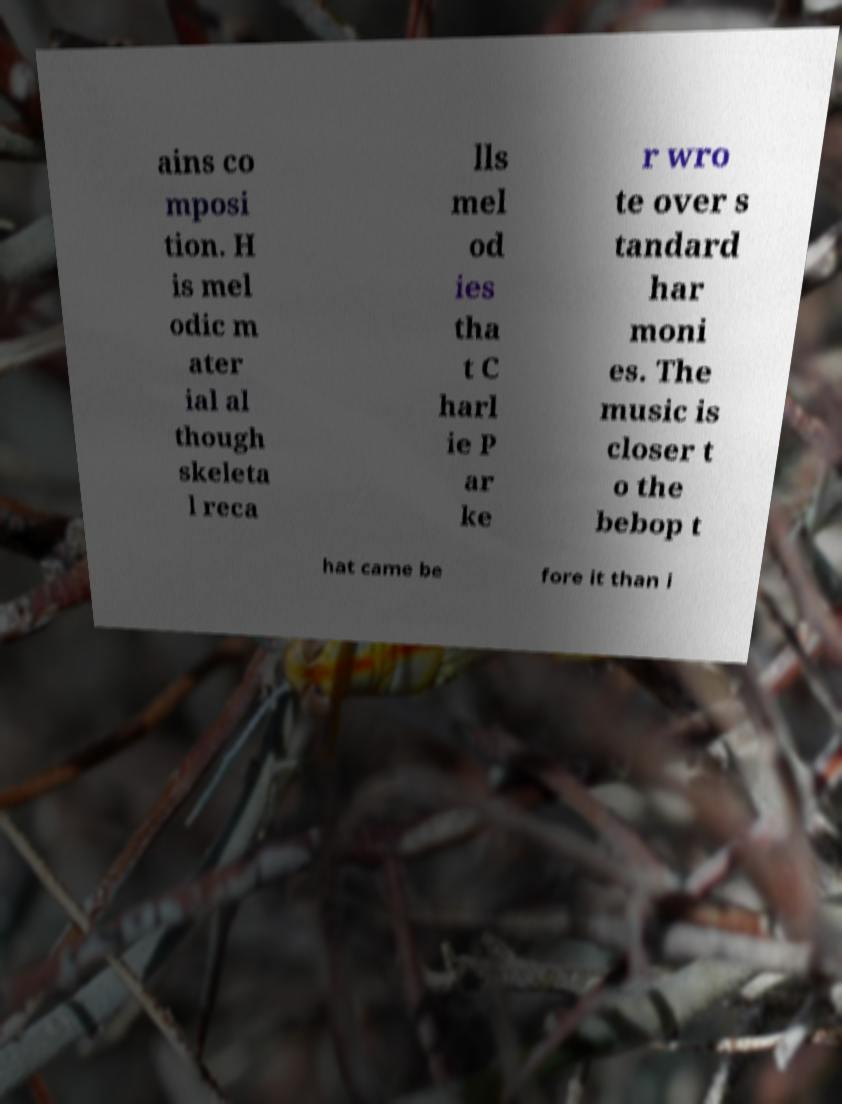Can you read and provide the text displayed in the image?This photo seems to have some interesting text. Can you extract and type it out for me? ains co mposi tion. H is mel odic m ater ial al though skeleta l reca lls mel od ies tha t C harl ie P ar ke r wro te over s tandard har moni es. The music is closer t o the bebop t hat came be fore it than i 